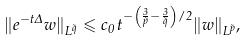<formula> <loc_0><loc_0><loc_500><loc_500>\| e ^ { - t \Delta } w \| _ { L ^ { \tilde { q } } } \leqslant c _ { 0 } \, t ^ { - \left ( \frac { 3 } { \tilde { p } } - \frac { 3 } { \tilde { q } } \right ) / 2 } \| w \| _ { L ^ { \tilde { p } } } ,</formula> 